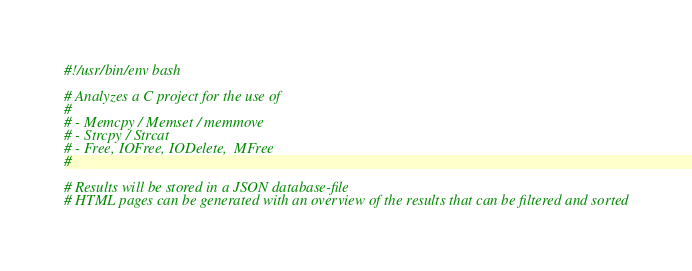Convert code to text. <code><loc_0><loc_0><loc_500><loc_500><_Bash_>#!/usr/bin/env bash

# Analyzes a C project for the use of
#
# - Memcpy / Memset / memmove
# - Strcpy / Strcat
# - Free, IOFree, IODelete,  MFree
#

# Results will be stored in a JSON database-file
# HTML pages can be generated with an overview of the results that can be filtered and sorted
</code> 